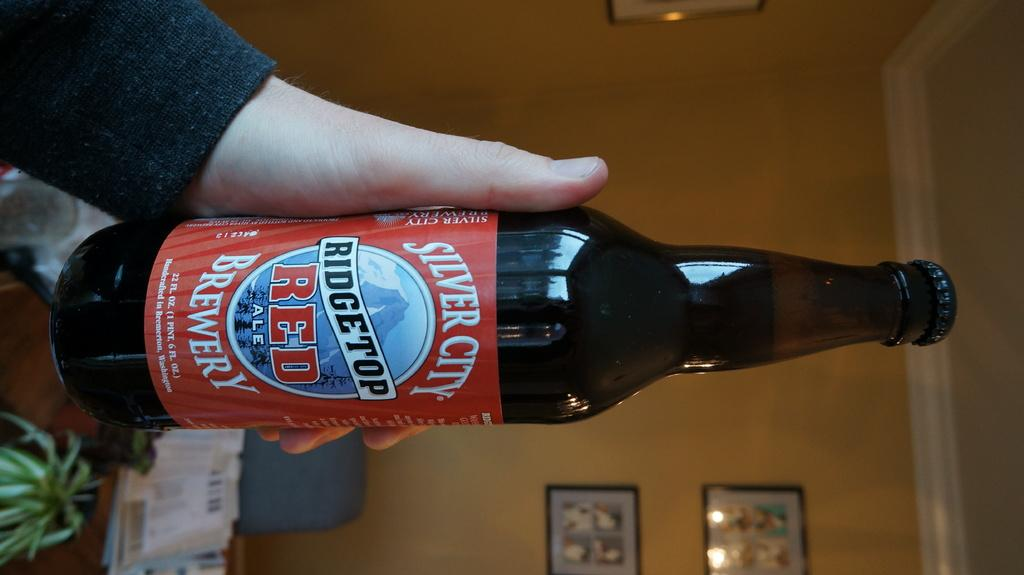<image>
Provide a brief description of the given image. A man is holding a bottle of Silver City Brewery Ale. 